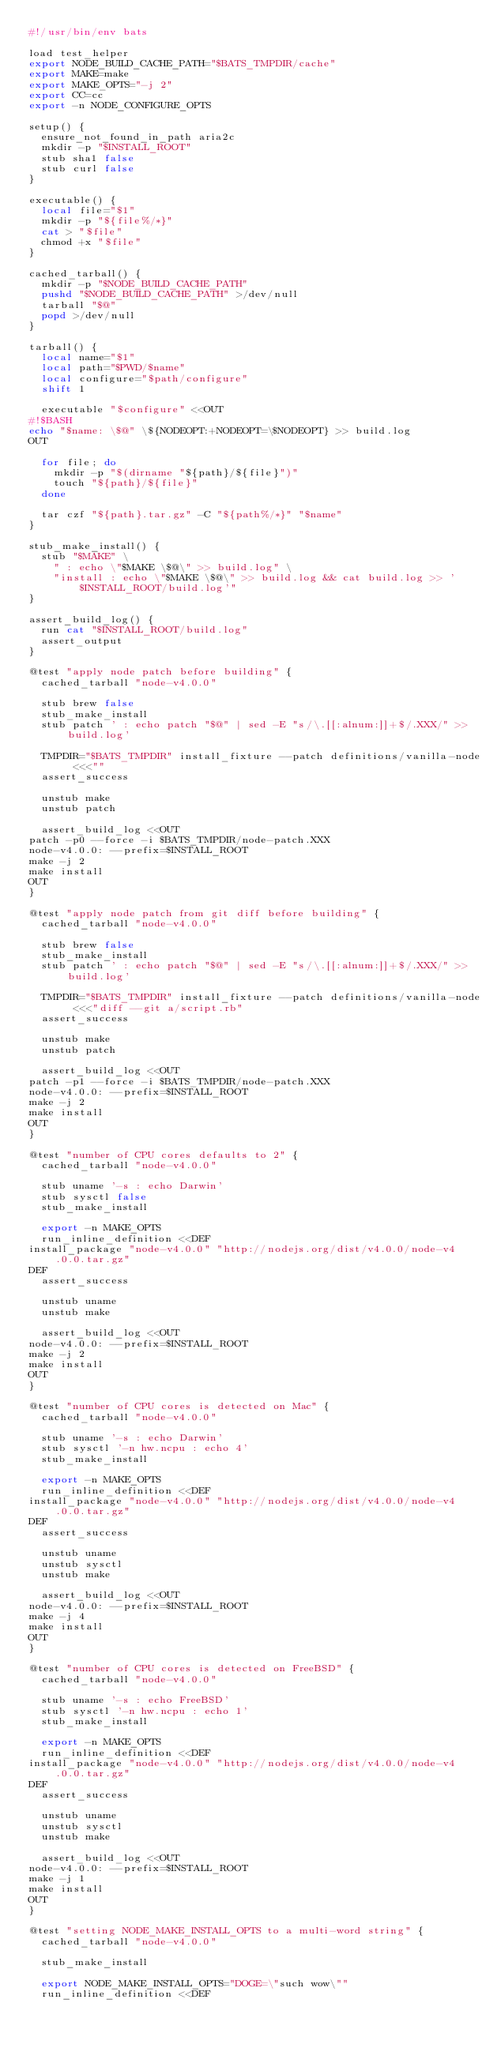Convert code to text. <code><loc_0><loc_0><loc_500><loc_500><_Bash_>#!/usr/bin/env bats

load test_helper
export NODE_BUILD_CACHE_PATH="$BATS_TMPDIR/cache"
export MAKE=make
export MAKE_OPTS="-j 2"
export CC=cc
export -n NODE_CONFIGURE_OPTS

setup() {
  ensure_not_found_in_path aria2c
  mkdir -p "$INSTALL_ROOT"
  stub sha1 false
  stub curl false
}

executable() {
  local file="$1"
  mkdir -p "${file%/*}"
  cat > "$file"
  chmod +x "$file"
}

cached_tarball() {
  mkdir -p "$NODE_BUILD_CACHE_PATH"
  pushd "$NODE_BUILD_CACHE_PATH" >/dev/null
  tarball "$@"
  popd >/dev/null
}

tarball() {
  local name="$1"
  local path="$PWD/$name"
  local configure="$path/configure"
  shift 1

  executable "$configure" <<OUT
#!$BASH
echo "$name: \$@" \${NODEOPT:+NODEOPT=\$NODEOPT} >> build.log
OUT

  for file; do
    mkdir -p "$(dirname "${path}/${file}")"
    touch "${path}/${file}"
  done

  tar czf "${path}.tar.gz" -C "${path%/*}" "$name"
}

stub_make_install() {
  stub "$MAKE" \
    " : echo \"$MAKE \$@\" >> build.log" \
    "install : echo \"$MAKE \$@\" >> build.log && cat build.log >> '$INSTALL_ROOT/build.log'"
}

assert_build_log() {
  run cat "$INSTALL_ROOT/build.log"
  assert_output
}

@test "apply node patch before building" {
  cached_tarball "node-v4.0.0"

  stub brew false
  stub_make_install
  stub patch ' : echo patch "$@" | sed -E "s/\.[[:alnum:]]+$/.XXX/" >> build.log'

  TMPDIR="$BATS_TMPDIR" install_fixture --patch definitions/vanilla-node <<<""
  assert_success

  unstub make
  unstub patch

  assert_build_log <<OUT
patch -p0 --force -i $BATS_TMPDIR/node-patch.XXX
node-v4.0.0: --prefix=$INSTALL_ROOT
make -j 2
make install
OUT
}

@test "apply node patch from git diff before building" {
  cached_tarball "node-v4.0.0"

  stub brew false
  stub_make_install
  stub patch ' : echo patch "$@" | sed -E "s/\.[[:alnum:]]+$/.XXX/" >> build.log'

  TMPDIR="$BATS_TMPDIR" install_fixture --patch definitions/vanilla-node <<<"diff --git a/script.rb"
  assert_success

  unstub make
  unstub patch

  assert_build_log <<OUT
patch -p1 --force -i $BATS_TMPDIR/node-patch.XXX
node-v4.0.0: --prefix=$INSTALL_ROOT
make -j 2
make install
OUT
}

@test "number of CPU cores defaults to 2" {
  cached_tarball "node-v4.0.0"

  stub uname '-s : echo Darwin'
  stub sysctl false
  stub_make_install

  export -n MAKE_OPTS
  run_inline_definition <<DEF
install_package "node-v4.0.0" "http://nodejs.org/dist/v4.0.0/node-v4.0.0.tar.gz"
DEF
  assert_success

  unstub uname
  unstub make

  assert_build_log <<OUT
node-v4.0.0: --prefix=$INSTALL_ROOT
make -j 2
make install
OUT
}

@test "number of CPU cores is detected on Mac" {
  cached_tarball "node-v4.0.0"

  stub uname '-s : echo Darwin'
  stub sysctl '-n hw.ncpu : echo 4'
  stub_make_install

  export -n MAKE_OPTS
  run_inline_definition <<DEF
install_package "node-v4.0.0" "http://nodejs.org/dist/v4.0.0/node-v4.0.0.tar.gz"
DEF
  assert_success

  unstub uname
  unstub sysctl
  unstub make

  assert_build_log <<OUT
node-v4.0.0: --prefix=$INSTALL_ROOT
make -j 4
make install
OUT
}

@test "number of CPU cores is detected on FreeBSD" {
  cached_tarball "node-v4.0.0"

  stub uname '-s : echo FreeBSD'
  stub sysctl '-n hw.ncpu : echo 1'
  stub_make_install

  export -n MAKE_OPTS
  run_inline_definition <<DEF
install_package "node-v4.0.0" "http://nodejs.org/dist/v4.0.0/node-v4.0.0.tar.gz"
DEF
  assert_success

  unstub uname
  unstub sysctl
  unstub make

  assert_build_log <<OUT
node-v4.0.0: --prefix=$INSTALL_ROOT
make -j 1
make install
OUT
}

@test "setting NODE_MAKE_INSTALL_OPTS to a multi-word string" {
  cached_tarball "node-v4.0.0"

  stub_make_install

  export NODE_MAKE_INSTALL_OPTS="DOGE=\"such wow\""
  run_inline_definition <<DEF</code> 